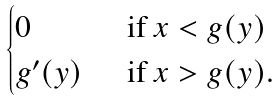<formula> <loc_0><loc_0><loc_500><loc_500>\begin{cases} 0 \, & \text { if } x < g ( y ) \\ g ^ { \prime } ( y ) \, & \text { if } x > g ( y ) . \end{cases}</formula> 